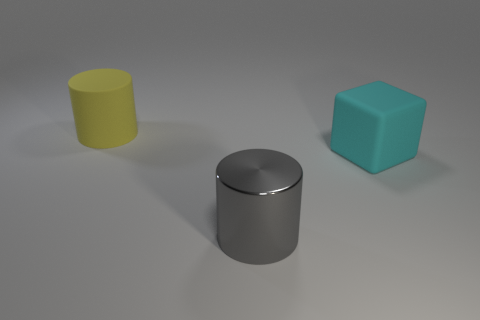Add 3 big cyan blocks. How many objects exist? 6 Subtract all cylinders. How many objects are left? 1 Add 3 tiny brown metallic spheres. How many tiny brown metallic spheres exist? 3 Subtract 0 blue cubes. How many objects are left? 3 Subtract all big blue shiny things. Subtract all big gray things. How many objects are left? 2 Add 3 big cubes. How many big cubes are left? 4 